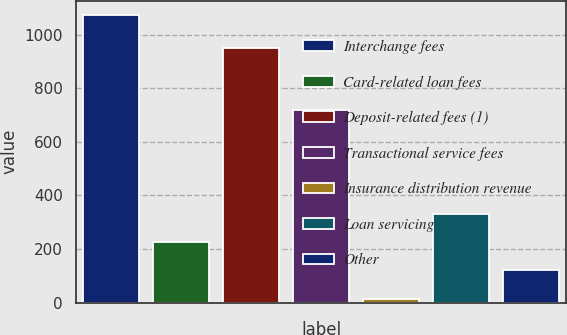Convert chart. <chart><loc_0><loc_0><loc_500><loc_500><bar_chart><fcel>Interchange fees<fcel>Card-related loan fees<fcel>Deposit-related fees (1)<fcel>Transactional service fees<fcel>Insurance distribution revenue<fcel>Loan servicing<fcel>Other<nl><fcel>1072<fcel>225.6<fcel>949<fcel>718<fcel>14<fcel>331.4<fcel>119.8<nl></chart> 